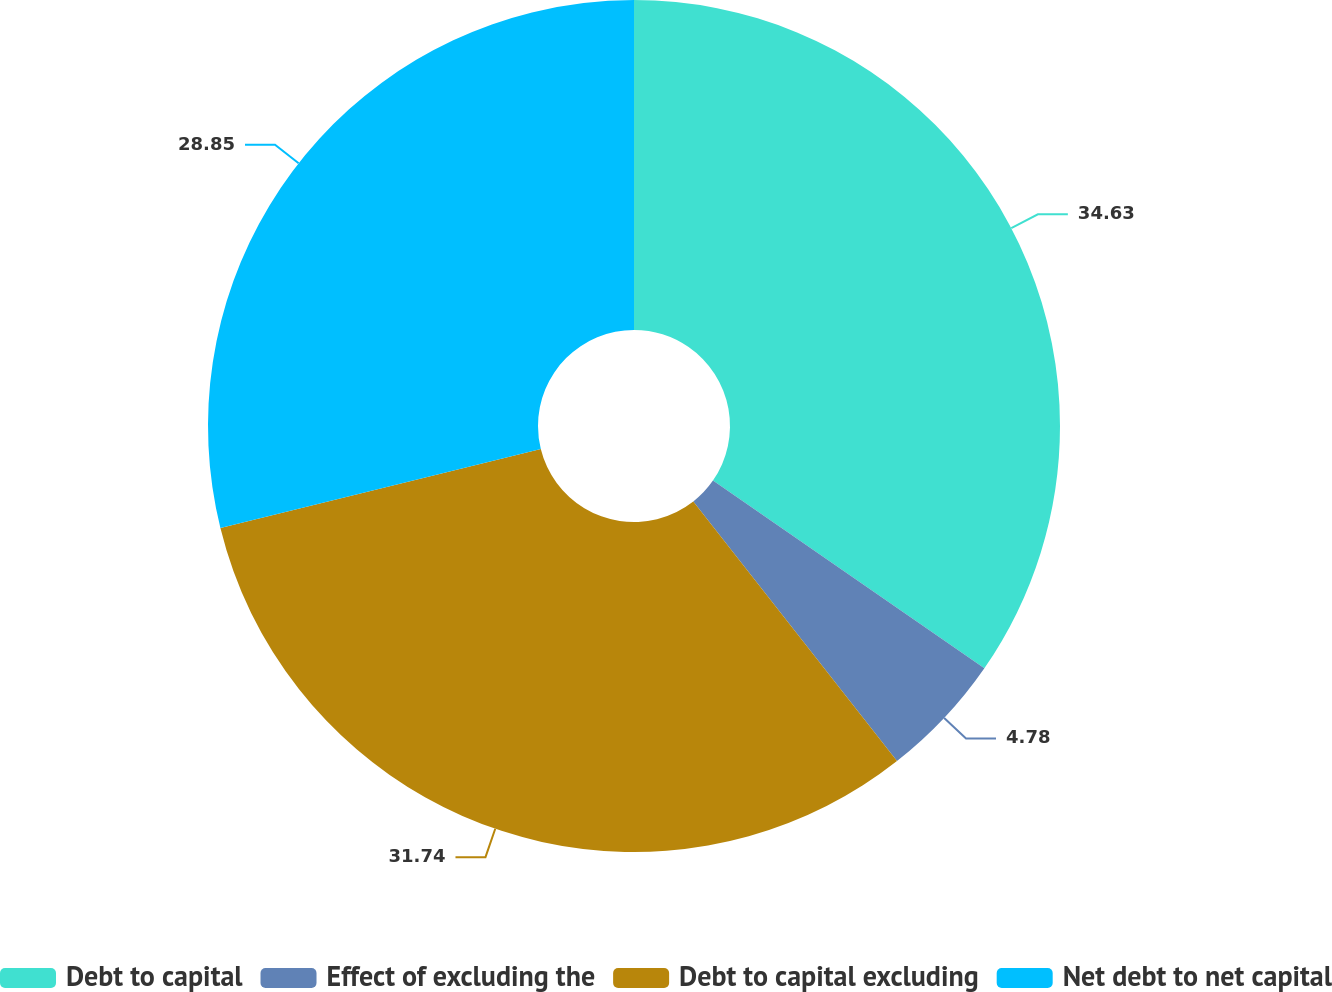Convert chart to OTSL. <chart><loc_0><loc_0><loc_500><loc_500><pie_chart><fcel>Debt to capital<fcel>Effect of excluding the<fcel>Debt to capital excluding<fcel>Net debt to net capital<nl><fcel>34.63%<fcel>4.78%<fcel>31.74%<fcel>28.85%<nl></chart> 